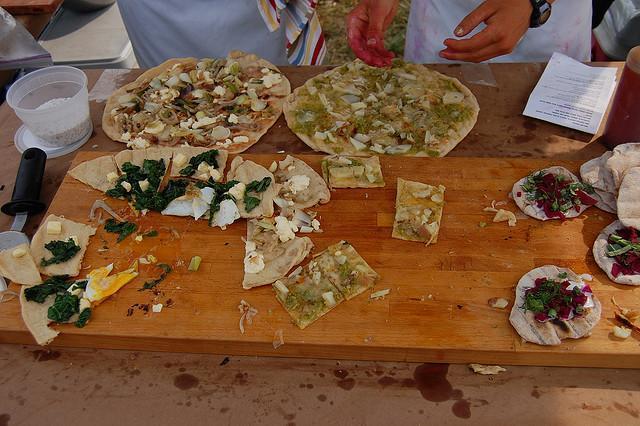How many people are there?
Give a very brief answer. 2. How many pizzas are visible?
Give a very brief answer. 4. How many dining tables can be seen?
Give a very brief answer. 1. 